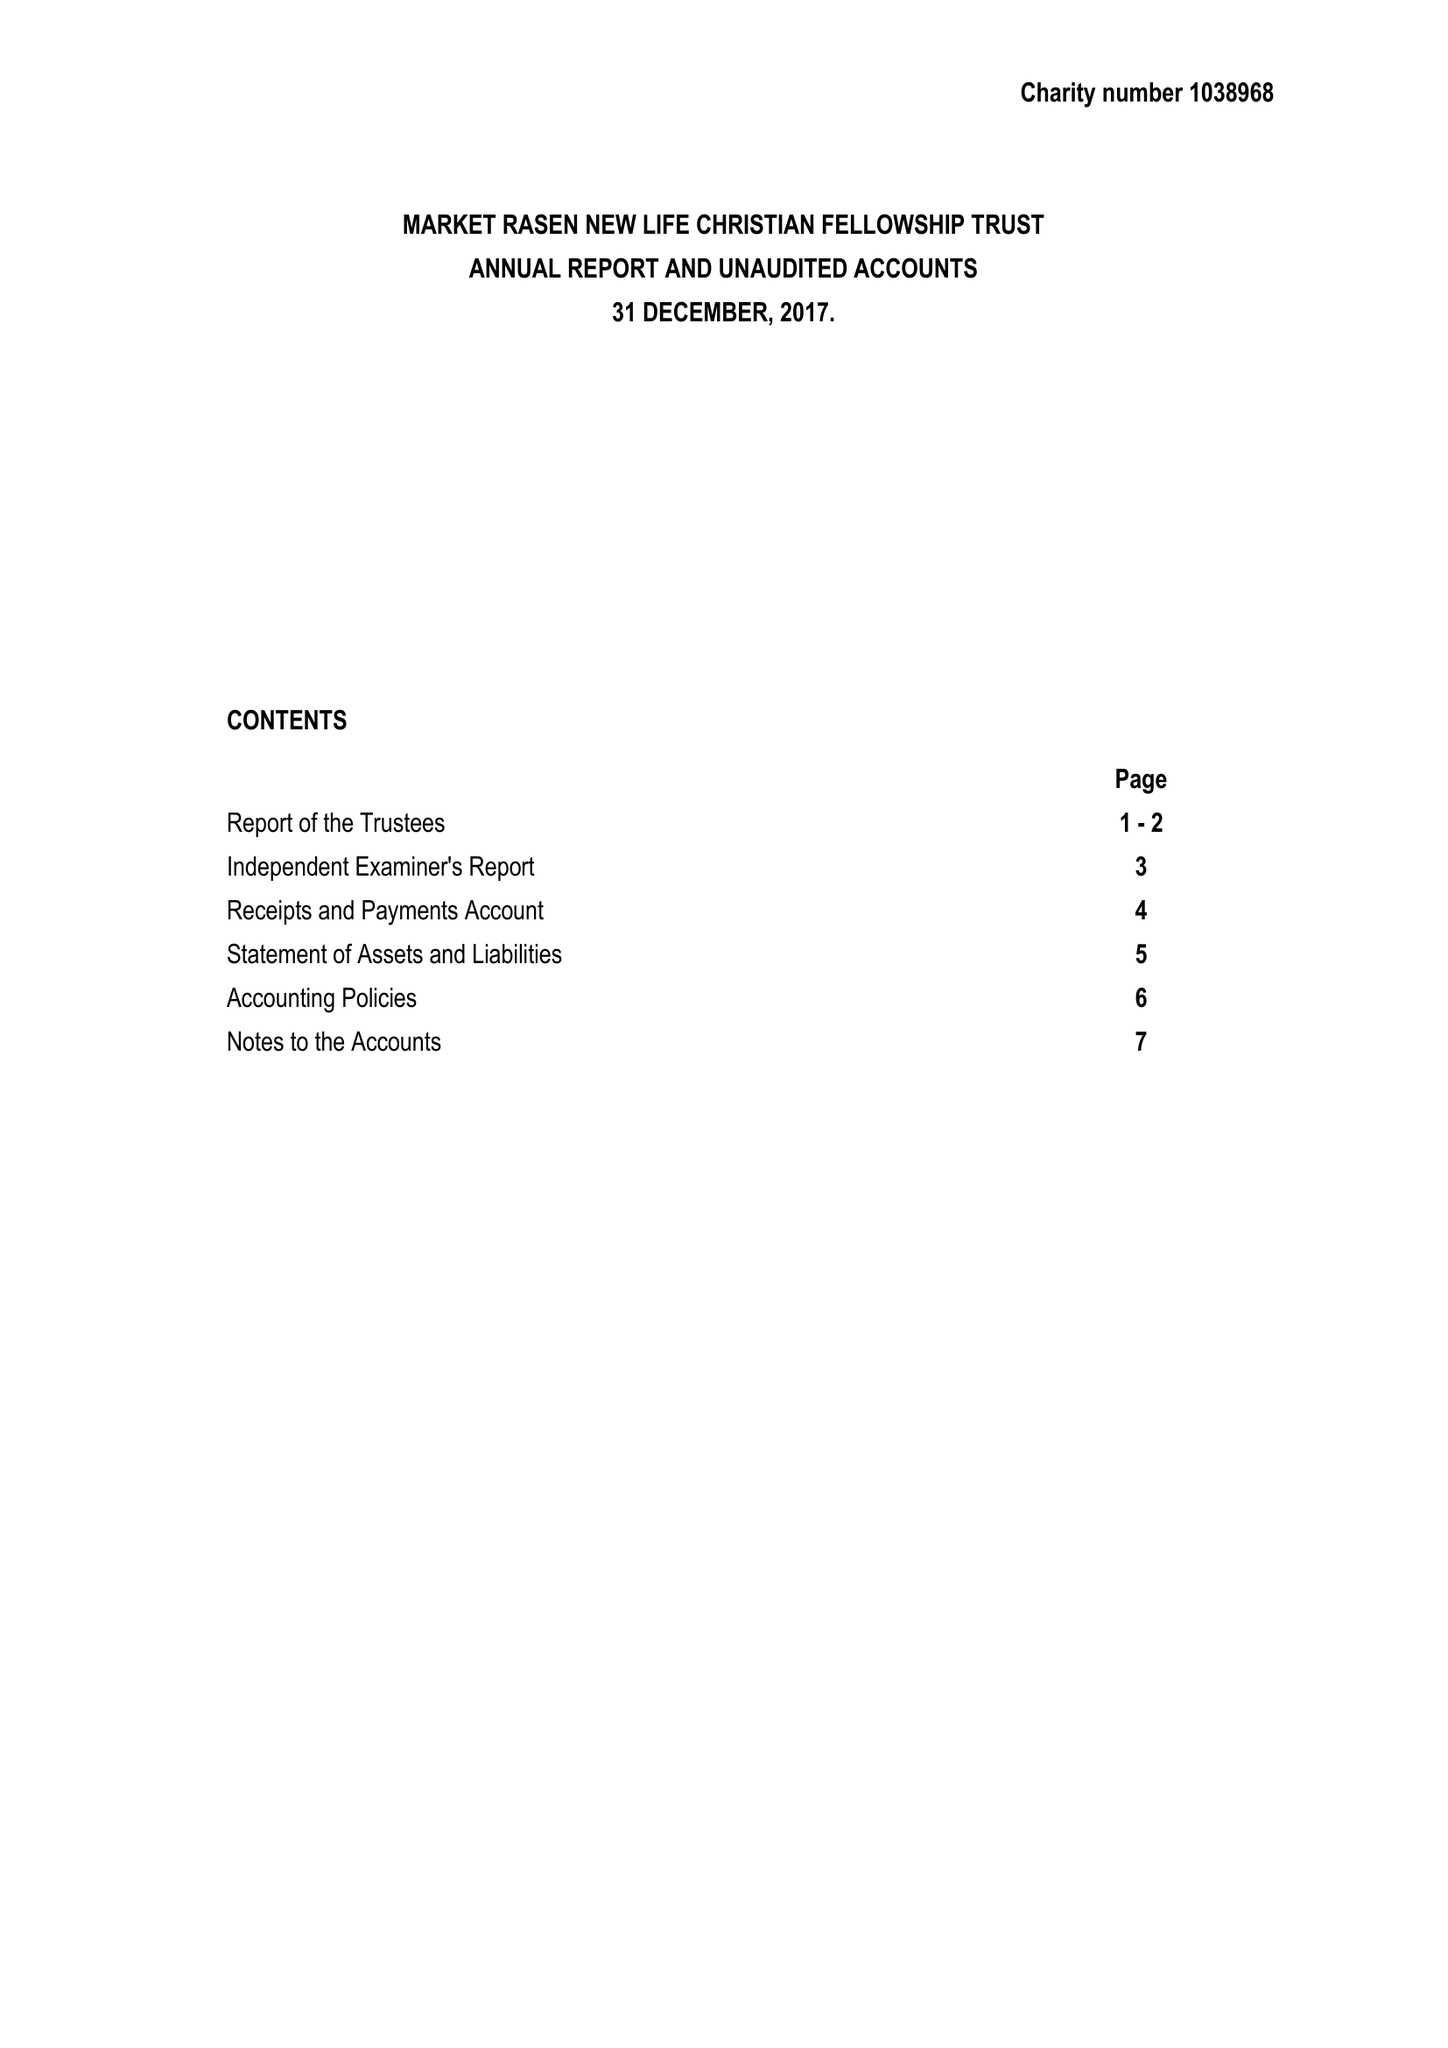What is the value for the charity_name?
Answer the question using a single word or phrase. Market Rasen New Life Christian Fellowship Trust 